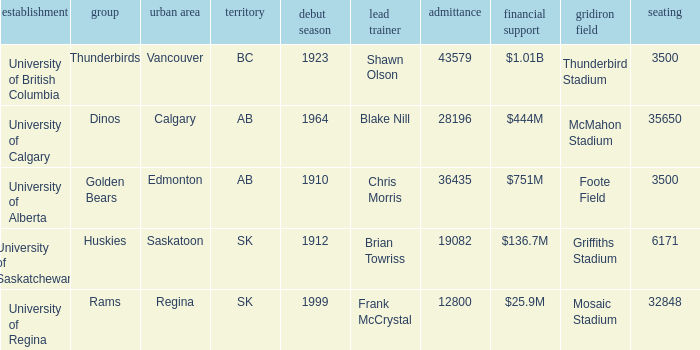How many cities have an enrollment of 19082? 1.0. 